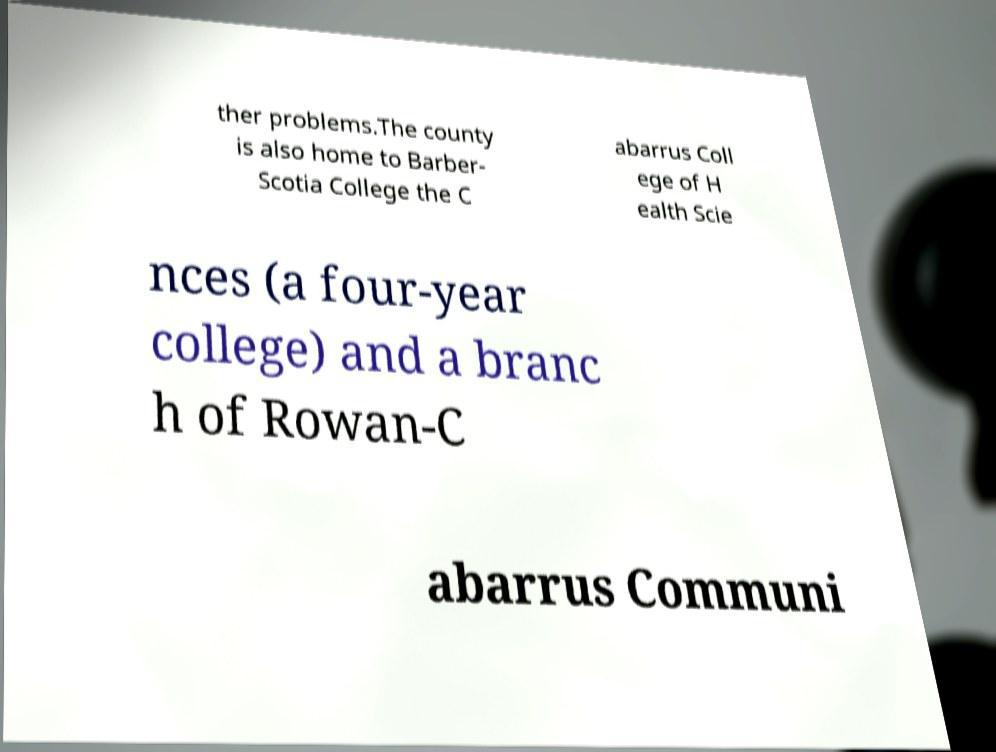What messages or text are displayed in this image? I need them in a readable, typed format. ther problems.The county is also home to Barber- Scotia College the C abarrus Coll ege of H ealth Scie nces (a four-year college) and a branc h of Rowan-C abarrus Communi 